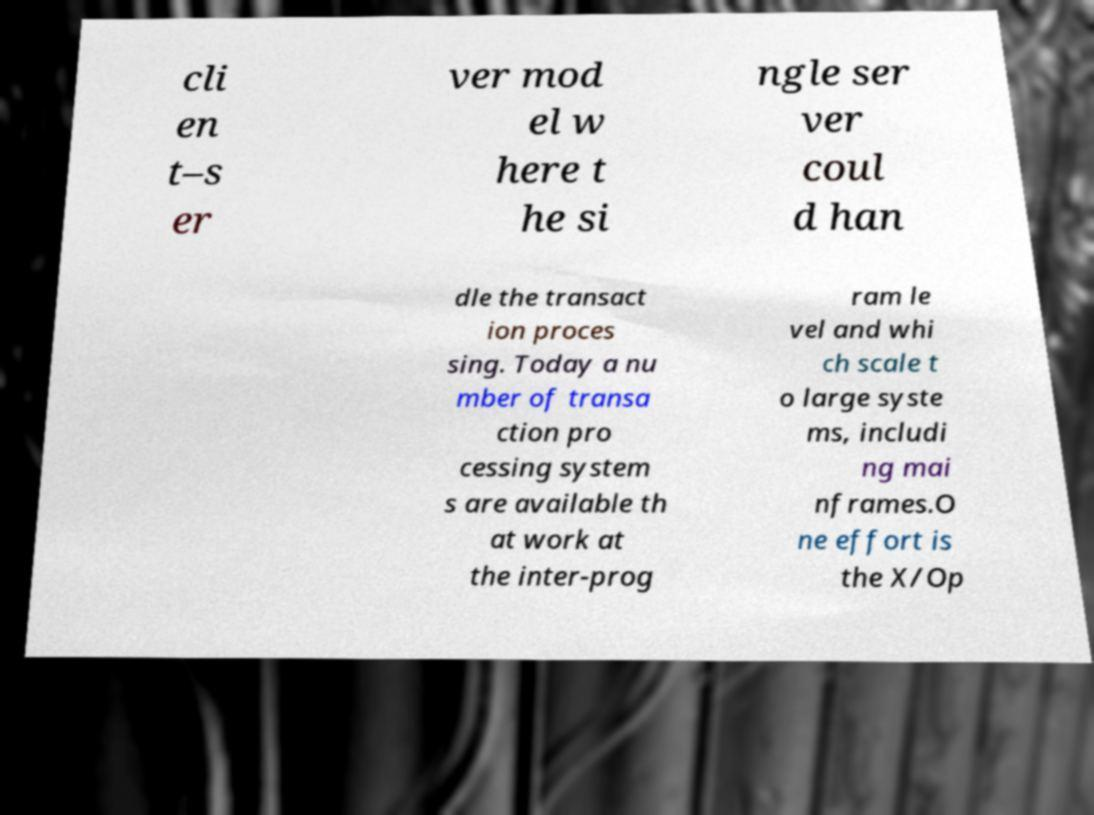There's text embedded in this image that I need extracted. Can you transcribe it verbatim? cli en t–s er ver mod el w here t he si ngle ser ver coul d han dle the transact ion proces sing. Today a nu mber of transa ction pro cessing system s are available th at work at the inter-prog ram le vel and whi ch scale t o large syste ms, includi ng mai nframes.O ne effort is the X/Op 